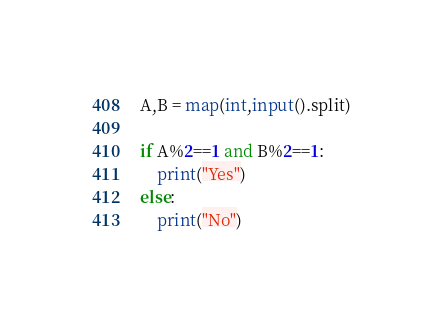<code> <loc_0><loc_0><loc_500><loc_500><_Python_>A,B = map(int,input().split)

if A%2==1 and B%2==1:
    print("Yes")
else:
    print("No")</code> 